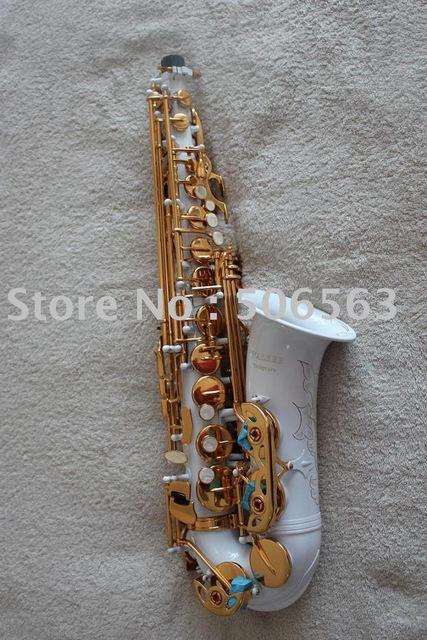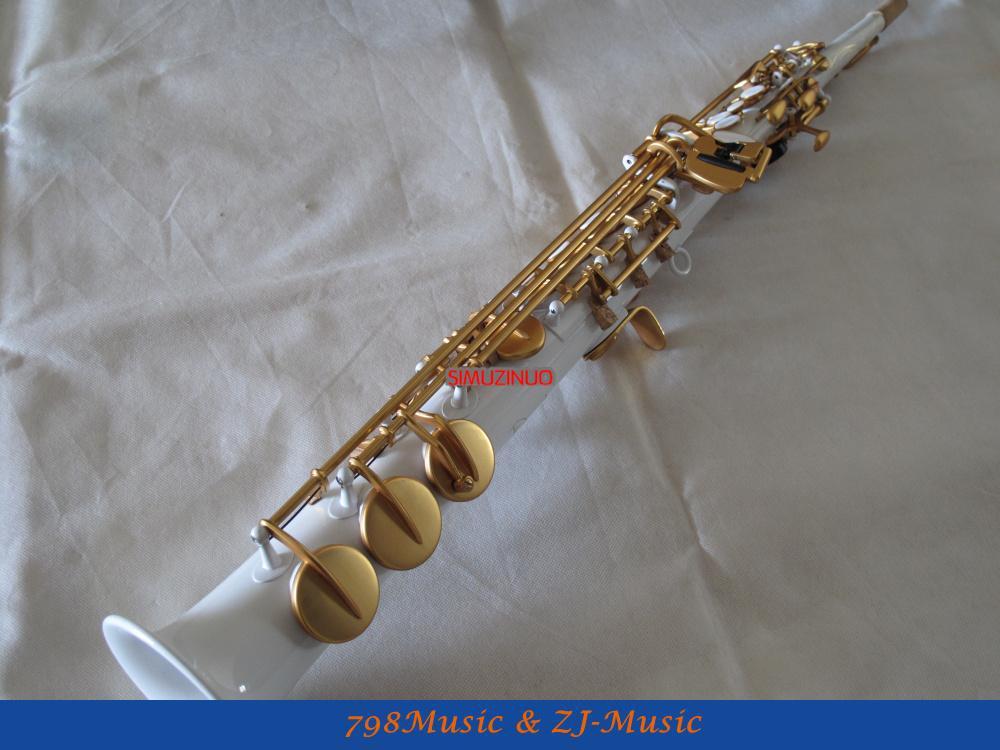The first image is the image on the left, the second image is the image on the right. Evaluate the accuracy of this statement regarding the images: "The left image shows a white saxophone witht turquoise on its gold buttons and its upturned bell facing right, and the right image shows a straight white instrument with its bell at the bottom.". Is it true? Answer yes or no. Yes. The first image is the image on the left, the second image is the image on the right. Considering the images on both sides, is "In at least one image there is a single long horn that base is white and keys are brass." valid? Answer yes or no. Yes. 